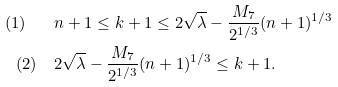Convert formula to latex. <formula><loc_0><loc_0><loc_500><loc_500>( 1 ) \quad & n + 1 \leq k + 1 \leq 2 \sqrt { \lambda } - \frac { M _ { 7 } } { 2 ^ { 1 / 3 } } ( n + 1 ) ^ { 1 / 3 } \\ ( 2 ) \quad & 2 \sqrt { \lambda } - \frac { M _ { 7 } } { 2 ^ { 1 / 3 } } ( n + 1 ) ^ { 1 / 3 } \leq k + 1 .</formula> 